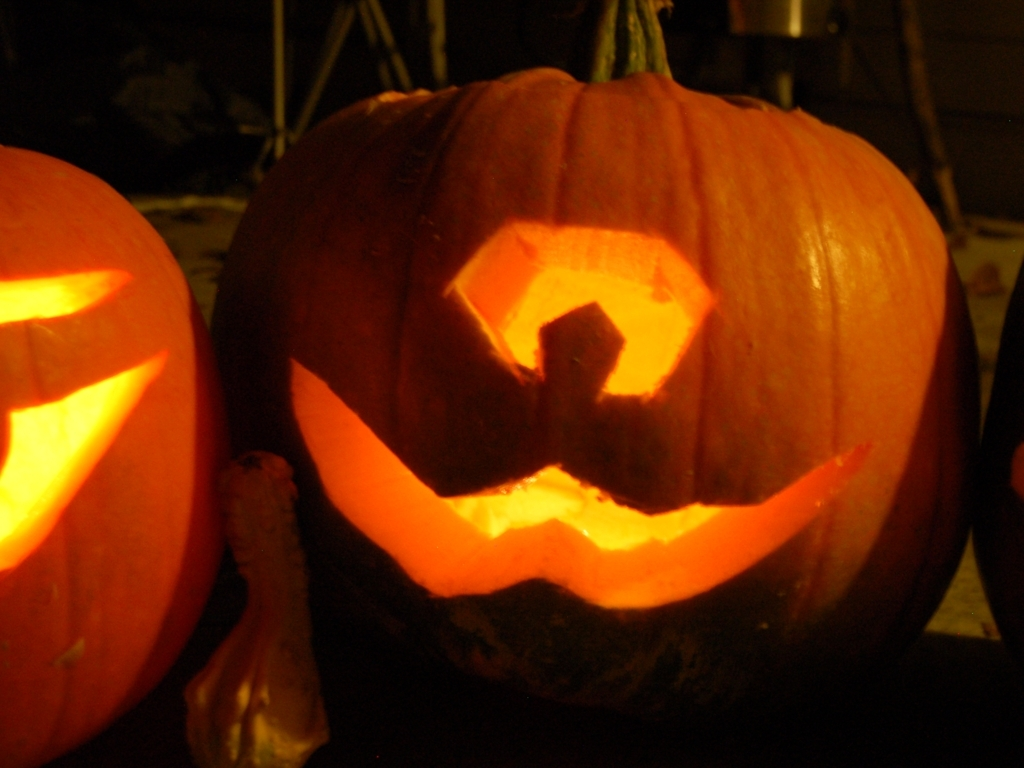Are there any quality issues with this image? The image displays a dimly lit carved pumpkin with a glowing interior, likely indicating it has a light source inside. The photo could benefit from better focus and lighting to enhance the visibility of the pumpkin's features and the surrounding environment for a clearer view. 